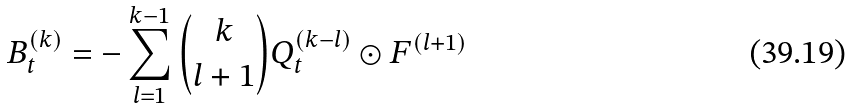<formula> <loc_0><loc_0><loc_500><loc_500>B _ { t } ^ { ( k ) } = - \sum _ { l = 1 } ^ { k - 1 } \binom { k } { l + 1 } Q _ { t } ^ { ( k - l ) } \odot F ^ { ( l + 1 ) }</formula> 